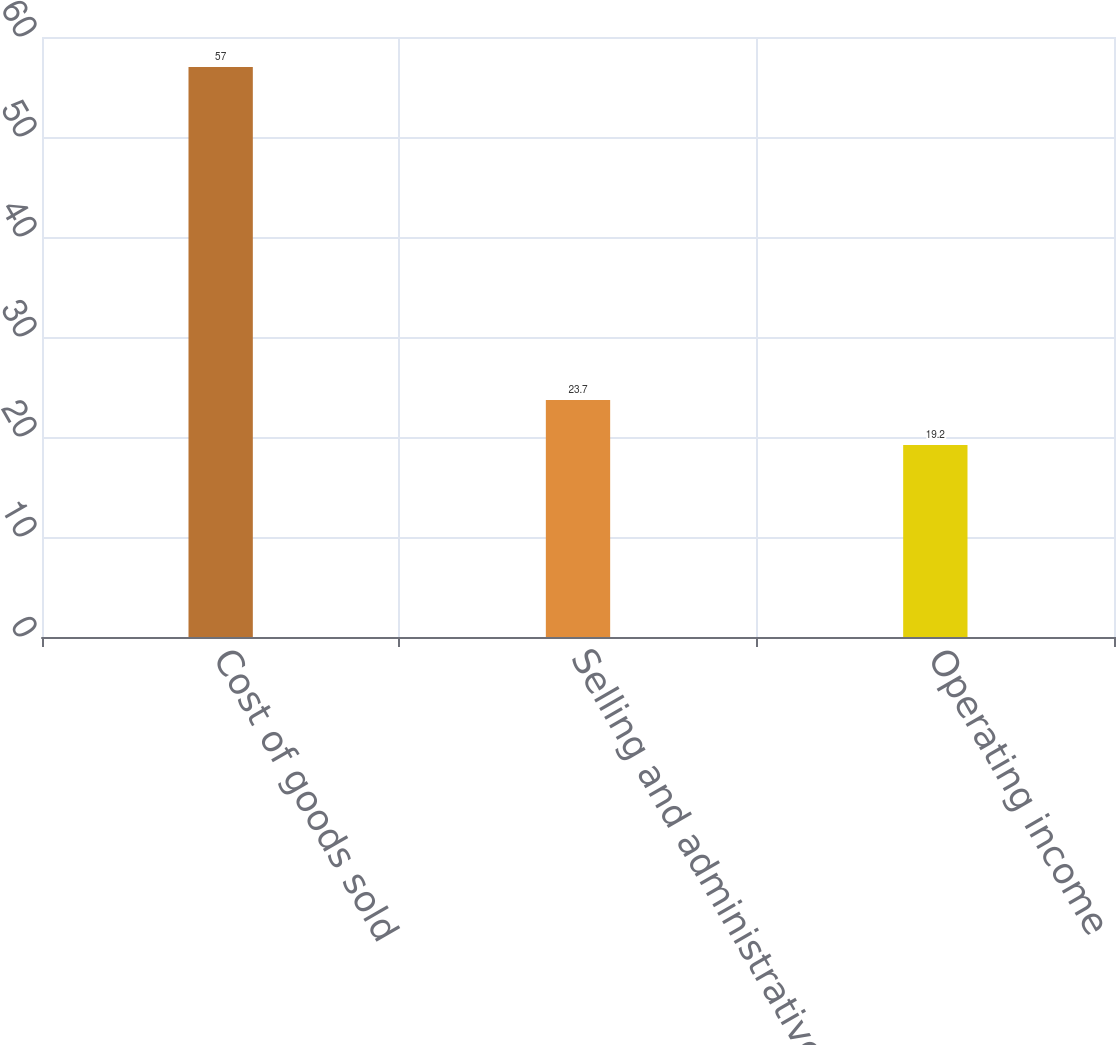Convert chart. <chart><loc_0><loc_0><loc_500><loc_500><bar_chart><fcel>Cost of goods sold<fcel>Selling and administrative<fcel>Operating income<nl><fcel>57<fcel>23.7<fcel>19.2<nl></chart> 